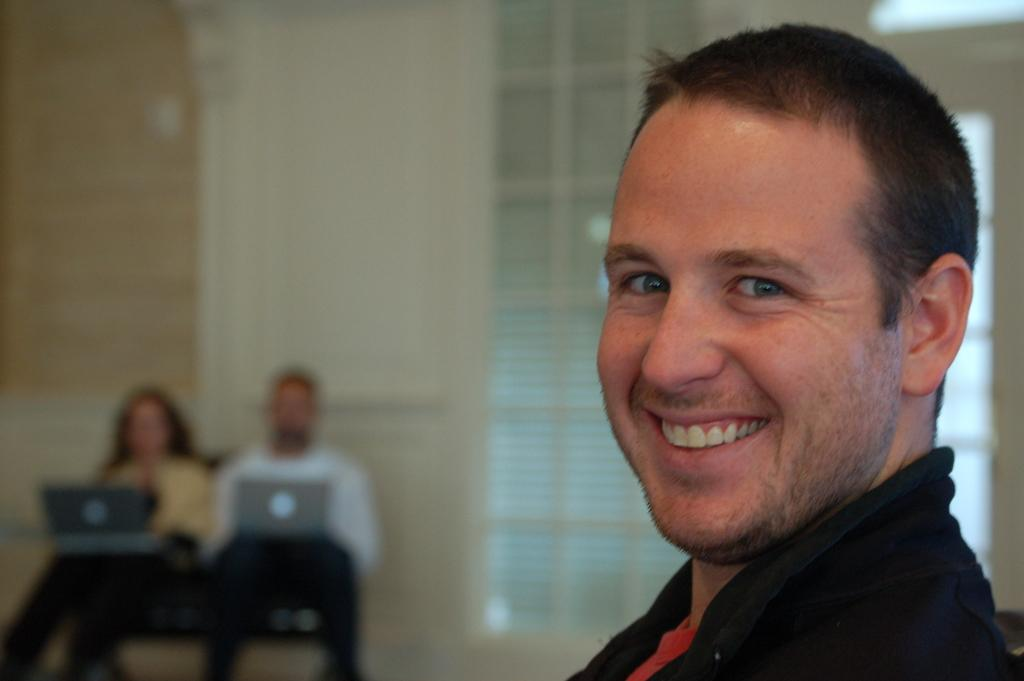What is the expression of the person in the image? The person in the image has a smile on his face. How many people are in the background of the image? There are two persons in the background of the image. What are the two persons in the background doing? The two persons in the background have laptops on their laps. What can be seen in the background of the image? There is a wall in the background of the image. What type of bun is visible on the person's head in the image? There is no bun visible on the person's head in the image. How does the fog affect the visibility of the people in the image? There is no fog present in the image, so it does not affect the visibility of the people. 